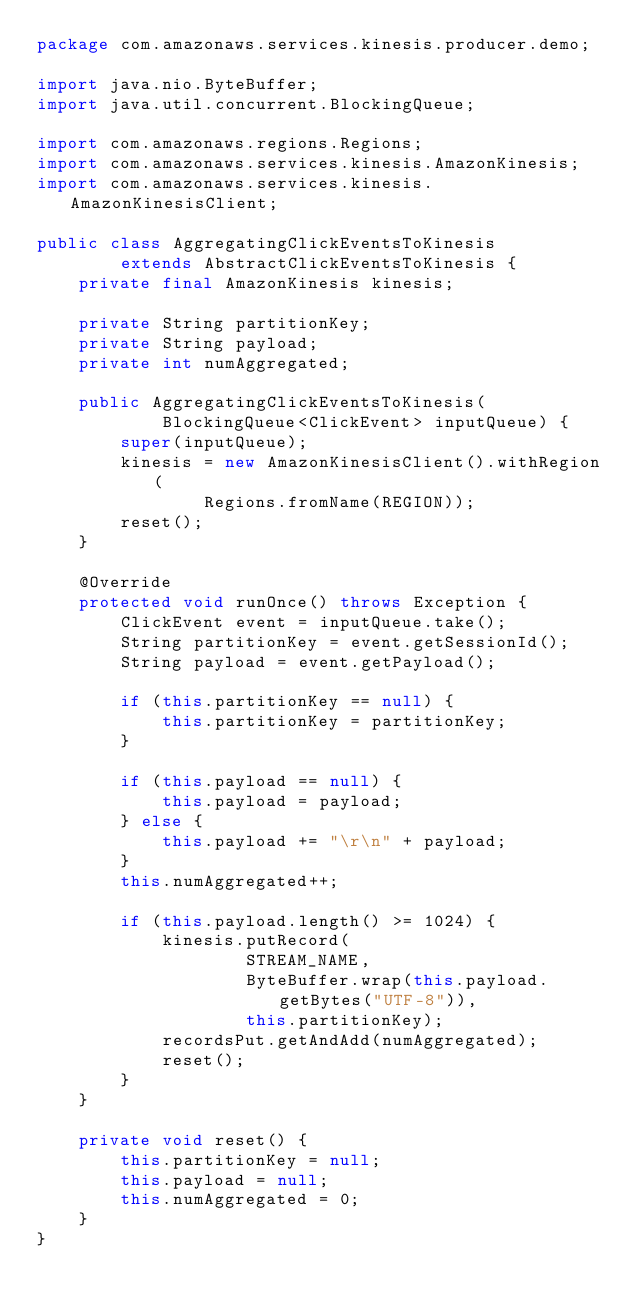<code> <loc_0><loc_0><loc_500><loc_500><_Java_>package com.amazonaws.services.kinesis.producer.demo;

import java.nio.ByteBuffer;
import java.util.concurrent.BlockingQueue;

import com.amazonaws.regions.Regions;
import com.amazonaws.services.kinesis.AmazonKinesis;
import com.amazonaws.services.kinesis.AmazonKinesisClient;

public class AggregatingClickEventsToKinesis
        extends AbstractClickEventsToKinesis {
    private final AmazonKinesis kinesis;

    private String partitionKey;
    private String payload;
    private int numAggregated;

    public AggregatingClickEventsToKinesis(
            BlockingQueue<ClickEvent> inputQueue) {
        super(inputQueue);
        kinesis = new AmazonKinesisClient().withRegion(
                Regions.fromName(REGION));
        reset();
    }

    @Override
    protected void runOnce() throws Exception {
        ClickEvent event = inputQueue.take();
        String partitionKey = event.getSessionId();
        String payload = event.getPayload();

        if (this.partitionKey == null) {
            this.partitionKey = partitionKey;
        }

        if (this.payload == null) {
            this.payload = payload;
        } else {
            this.payload += "\r\n" + payload;
        }
        this.numAggregated++;

        if (this.payload.length() >= 1024) {
            kinesis.putRecord(
                    STREAM_NAME,
                    ByteBuffer.wrap(this.payload.getBytes("UTF-8")),
                    this.partitionKey);
            recordsPut.getAndAdd(numAggregated);
            reset();
        }
    }

    private void reset() {
        this.partitionKey = null;
        this.payload = null;
        this.numAggregated = 0;
    }
}
</code> 